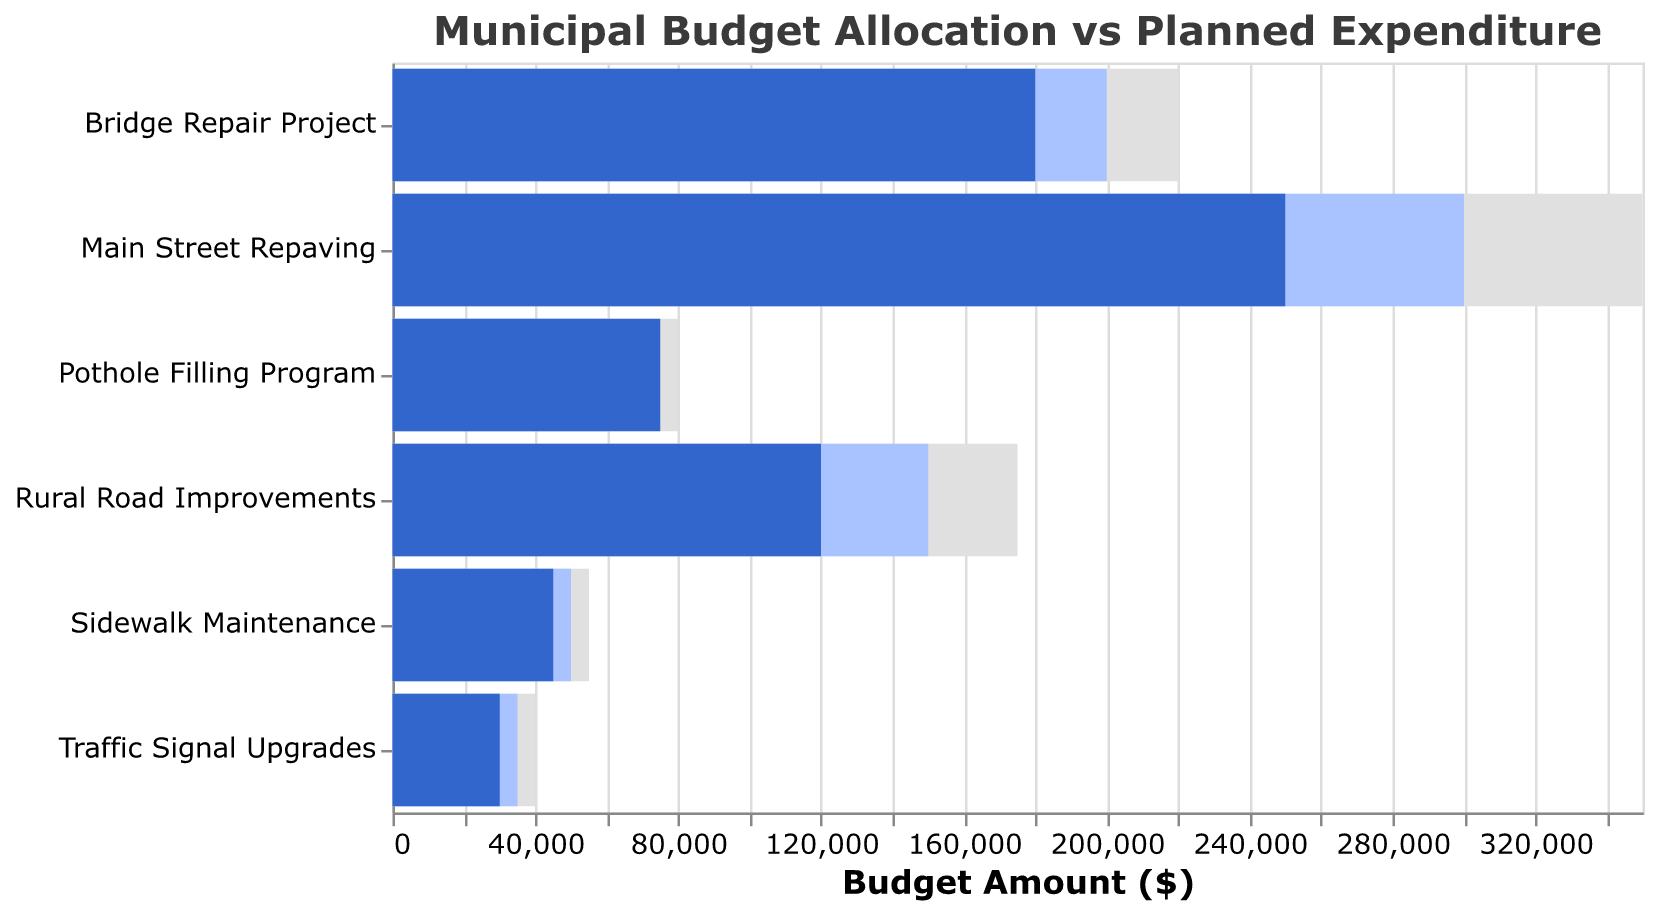How many projects in total are represented in this chart? To determine the total number of projects, one would simply count the number of unique titles listed on the y-axis. From "Main Street Repaving" to "Traffic Signal Upgrades," there are 6 projects in total.
Answer: 6 Which project has the highest planned expenditure? By comparing the planned expenditure (represented by the blue bars), one can see that "Main Street Repaving" has the highest planned expenditure of $300,000.
Answer: Main Street Repaving What is the total combined target budget for all the projects? To find the combined target budget, add up the target values for all the projects: 350000 + 220000 + 80000 + 55000 + 175000 + 40000 = 920000.
Answer: 920000 How much less is the actual expenditure compared to the target for "Rural Road Improvements"? The actual expenditure for "Rural Road Improvements" is $120,000 and the target is $175,000. The difference is 175000 - 120000 = $55,000.
Answer: 55000 Which project had an actual expenditure higher than its planned expenditure? To determine this, compare the heights of the bars representing actual and planned expenditures. The "Pothole Filling Program" has an actual expenditure of $75,000 which is higher than its planned expenditure of $60,000.
Answer: Pothole Filling Program Is there any project where the actual expenditure matches the planned expenditure? By inspecting the chart, it can be seen that none of the bars representing actual expenditure match exactly with the bars representing planned expenditure.
Answer: No For which project is the difference between the actual expenditure and the planned expenditure the smallest? To find the smallest difference, calculate the differences for each project: Main Street Repaving: 300000 - 250000 = 50000, Bridge Repair Project: 200000 - 180000 = 20000, Pothole Filling Program: 75000 - 60000 = 15000, Sidewalk Maintenance: 50000 - 45000 = 5000, Rural Road Improvements: 150000 - 120000 = 30000, Traffic Signal Upgrades: 35000 - 30000 = 5000. Both "Sidewalk Maintenance" and "Traffic Signal Upgrades" have a difference of $5,000, which is the smallest.
Answer: Sidewalk Maintenance, Traffic Signal Upgrades What is the average planned expenditure for all projects? Sum all the planned expenditures and divide by the number of projects: (300000 + 200000 + 60000 + 50000 + 150000 + 35000) / 6 = 795000 / 6 = 132500.
Answer: 132500 